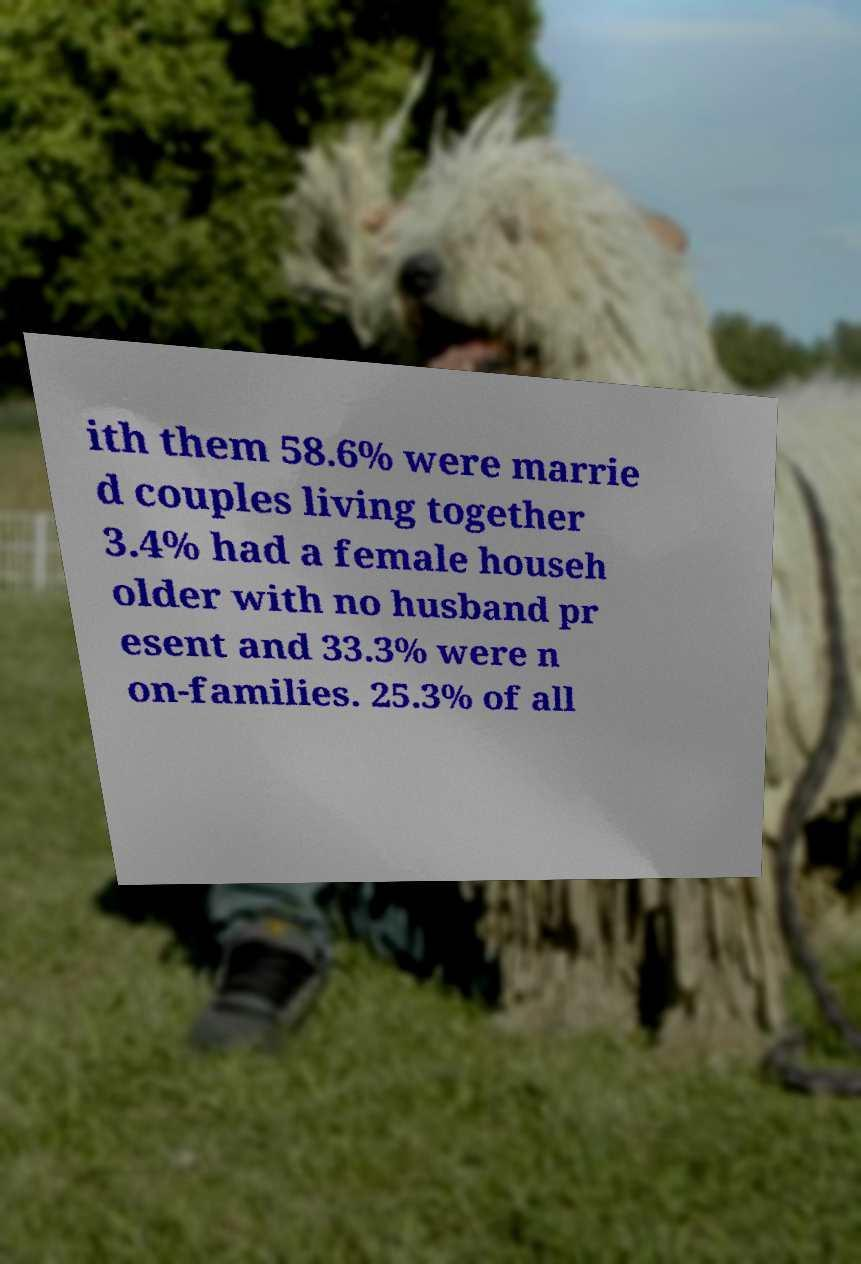Please read and relay the text visible in this image. What does it say? ith them 58.6% were marrie d couples living together 3.4% had a female househ older with no husband pr esent and 33.3% were n on-families. 25.3% of all 